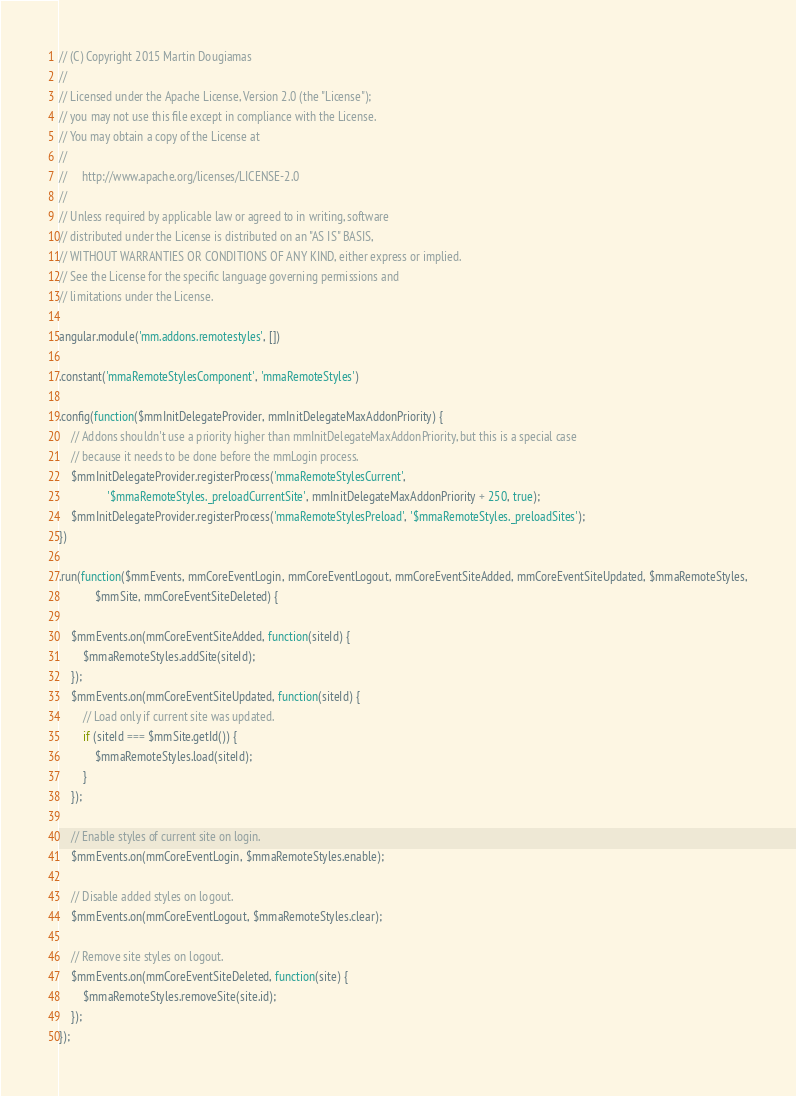<code> <loc_0><loc_0><loc_500><loc_500><_JavaScript_>// (C) Copyright 2015 Martin Dougiamas
//
// Licensed under the Apache License, Version 2.0 (the "License");
// you may not use this file except in compliance with the License.
// You may obtain a copy of the License at
//
//     http://www.apache.org/licenses/LICENSE-2.0
//
// Unless required by applicable law or agreed to in writing, software
// distributed under the License is distributed on an "AS IS" BASIS,
// WITHOUT WARRANTIES OR CONDITIONS OF ANY KIND, either express or implied.
// See the License for the specific language governing permissions and
// limitations under the License.

angular.module('mm.addons.remotestyles', [])

.constant('mmaRemoteStylesComponent', 'mmaRemoteStyles')

.config(function($mmInitDelegateProvider, mmInitDelegateMaxAddonPriority) {
    // Addons shouldn't use a priority higher than mmInitDelegateMaxAddonPriority, but this is a special case
    // because it needs to be done before the mmLogin process.
    $mmInitDelegateProvider.registerProcess('mmaRemoteStylesCurrent',
                '$mmaRemoteStyles._preloadCurrentSite', mmInitDelegateMaxAddonPriority + 250, true);
    $mmInitDelegateProvider.registerProcess('mmaRemoteStylesPreload', '$mmaRemoteStyles._preloadSites');
})

.run(function($mmEvents, mmCoreEventLogin, mmCoreEventLogout, mmCoreEventSiteAdded, mmCoreEventSiteUpdated, $mmaRemoteStyles,
            $mmSite, mmCoreEventSiteDeleted) {

    $mmEvents.on(mmCoreEventSiteAdded, function(siteId) {
        $mmaRemoteStyles.addSite(siteId);
    });
    $mmEvents.on(mmCoreEventSiteUpdated, function(siteId) {
        // Load only if current site was updated.
        if (siteId === $mmSite.getId()) {
            $mmaRemoteStyles.load(siteId);
        }
    });

    // Enable styles of current site on login.
    $mmEvents.on(mmCoreEventLogin, $mmaRemoteStyles.enable);

    // Disable added styles on logout.
    $mmEvents.on(mmCoreEventLogout, $mmaRemoteStyles.clear);

    // Remove site styles on logout.
    $mmEvents.on(mmCoreEventSiteDeleted, function(site) {
        $mmaRemoteStyles.removeSite(site.id);
    });
});
</code> 